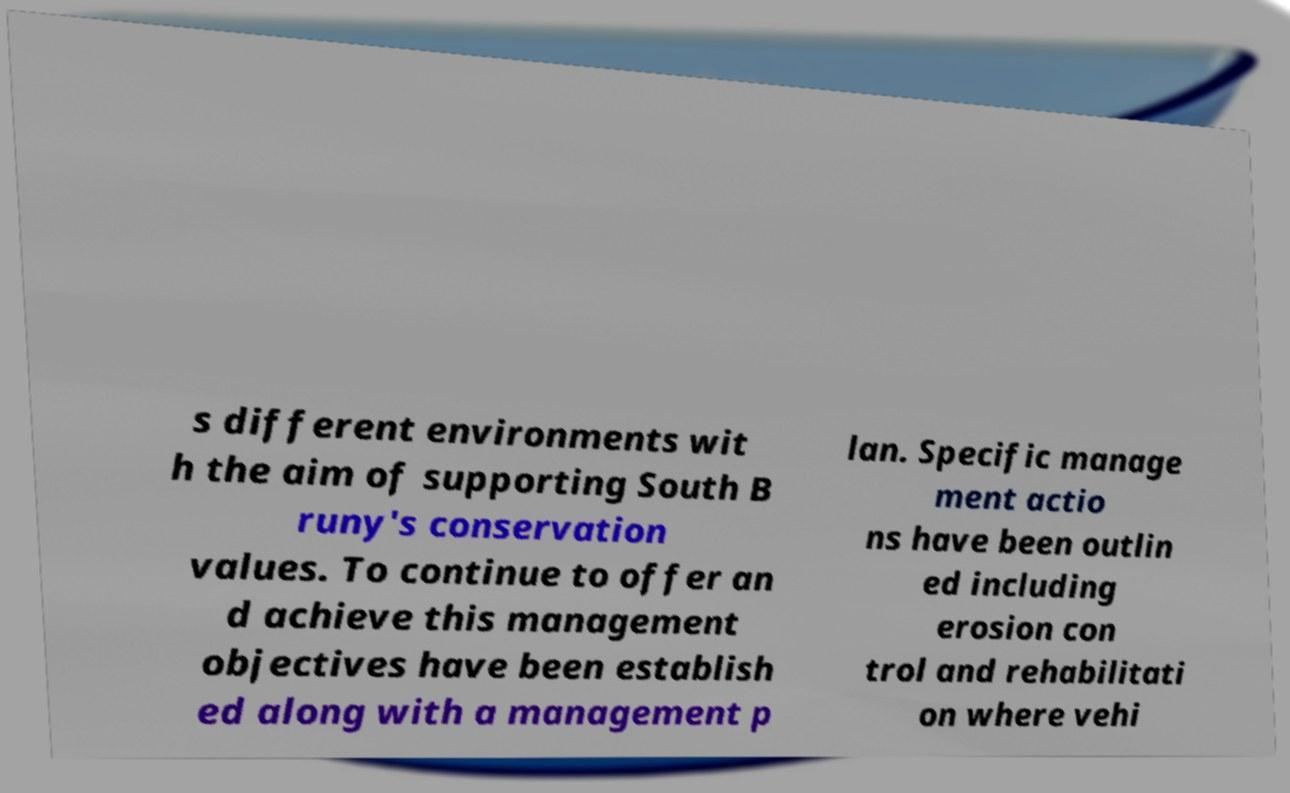Can you read and provide the text displayed in the image?This photo seems to have some interesting text. Can you extract and type it out for me? s different environments wit h the aim of supporting South B runy's conservation values. To continue to offer an d achieve this management objectives have been establish ed along with a management p lan. Specific manage ment actio ns have been outlin ed including erosion con trol and rehabilitati on where vehi 